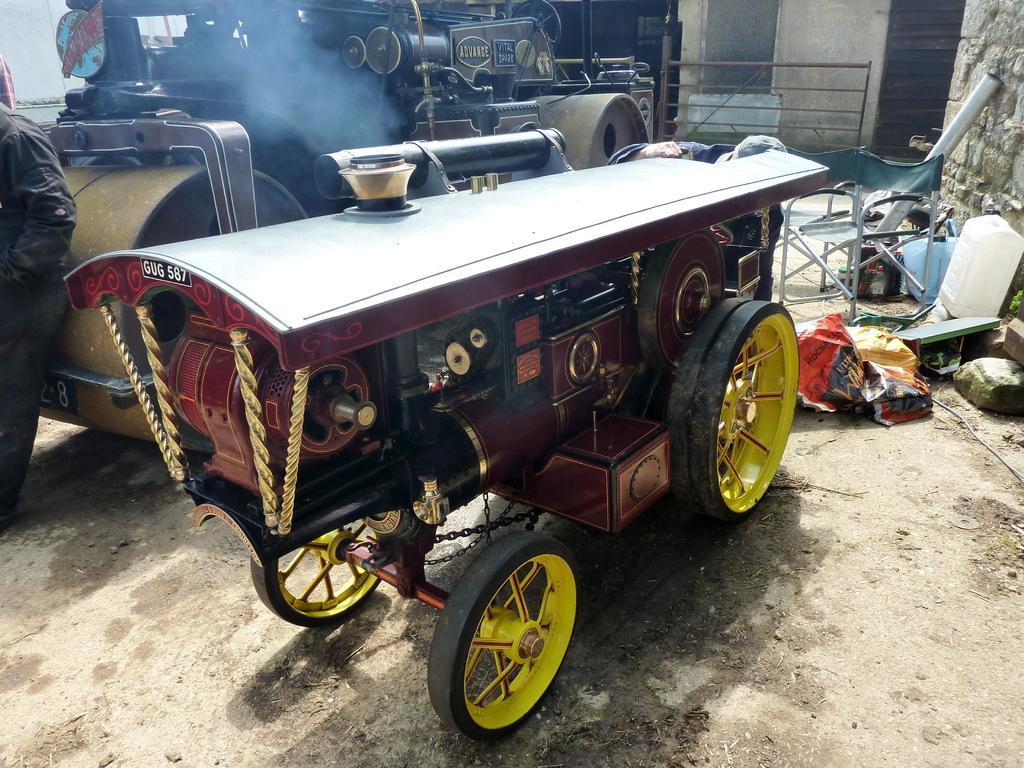Please provide a concise description of this image. In the image i can see the vehicles,wall,chair and some other objects. 